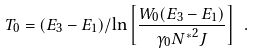Convert formula to latex. <formula><loc_0><loc_0><loc_500><loc_500>T _ { 0 } = ( E _ { 3 } - E _ { 1 } ) / \ln \left [ \frac { W _ { 0 } ( E _ { 3 } - E _ { 1 } ) } { \gamma _ { 0 } { N ^ { * } } ^ { 2 } J } \right ] \ .</formula> 